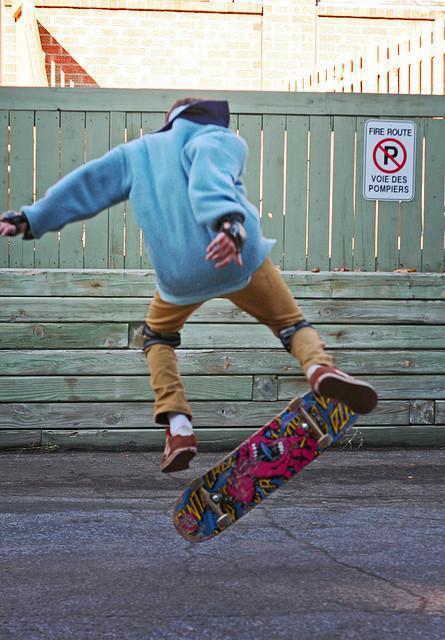How many wheels do you see?
Give a very brief answer. 4. 